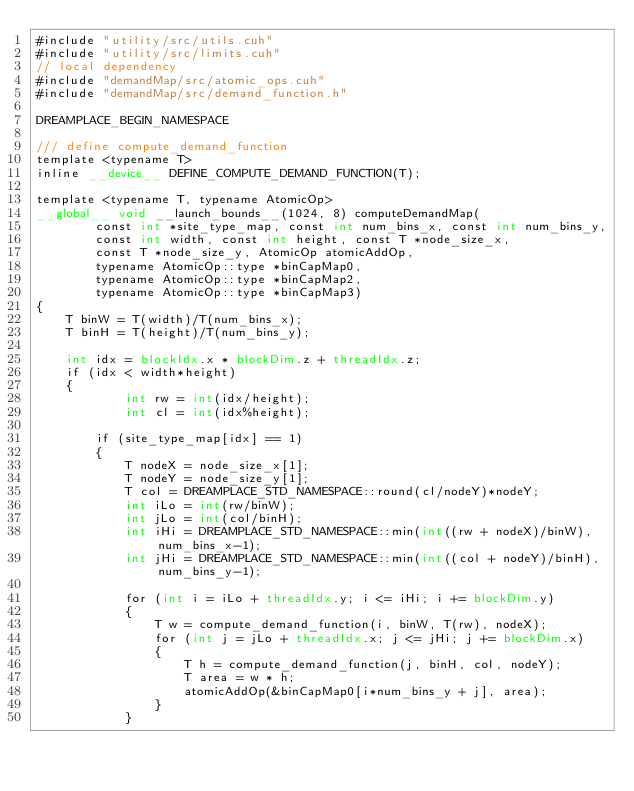<code> <loc_0><loc_0><loc_500><loc_500><_Cuda_>#include "utility/src/utils.cuh"
#include "utility/src/limits.cuh"
// local dependency
#include "demandMap/src/atomic_ops.cuh"
#include "demandMap/src/demand_function.h"

DREAMPLACE_BEGIN_NAMESPACE

/// define compute_demand_function 
template <typename T>
inline __device__ DEFINE_COMPUTE_DEMAND_FUNCTION(T);

template <typename T, typename AtomicOp>
__global__ void __launch_bounds__(1024, 8) computeDemandMap(
        const int *site_type_map, const int num_bins_x, const int num_bins_y, 
        const int width, const int height, const T *node_size_x, 
        const T *node_size_y, AtomicOp atomicAddOp,
        typename AtomicOp::type *binCapMap0,
        typename AtomicOp::type *binCapMap2,
        typename AtomicOp::type *binCapMap3)
{
    T binW = T(width)/T(num_bins_x);
    T binH = T(height)/T(num_bins_y);

    int idx = blockIdx.x * blockDim.z + threadIdx.z;
    if (idx < width*height)
    {
            int rw = int(idx/height);
            int cl = int(idx%height);

        if (site_type_map[idx] == 1)
        {
            T nodeX = node_size_x[1];
            T nodeY = node_size_y[1];
            T col = DREAMPLACE_STD_NAMESPACE::round(cl/nodeY)*nodeY;
            int iLo = int(rw/binW);
            int jLo = int(col/binH);
            int iHi = DREAMPLACE_STD_NAMESPACE::min(int((rw + nodeX)/binW), num_bins_x-1);
            int jHi = DREAMPLACE_STD_NAMESPACE::min(int((col + nodeY)/binH), num_bins_y-1);

            for (int i = iLo + threadIdx.y; i <= iHi; i += blockDim.y)
            {
                T w = compute_demand_function(i, binW, T(rw), nodeX);
                for (int j = jLo + threadIdx.x; j <= jHi; j += blockDim.x)
                {
                    T h = compute_demand_function(j, binH, col, nodeY);
                    T area = w * h;
                    atomicAddOp(&binCapMap0[i*num_bins_y + j], area);
                }
            }</code> 